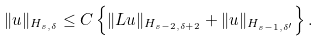<formula> <loc_0><loc_0><loc_500><loc_500>\| u \| _ { H _ { s , \delta } } \leq C \left \{ \| { L } u \| _ { H _ { s - 2 , \delta + 2 } } + \| u \| _ { H _ { s - 1 , \delta ^ { \prime } } } \right \} .</formula> 